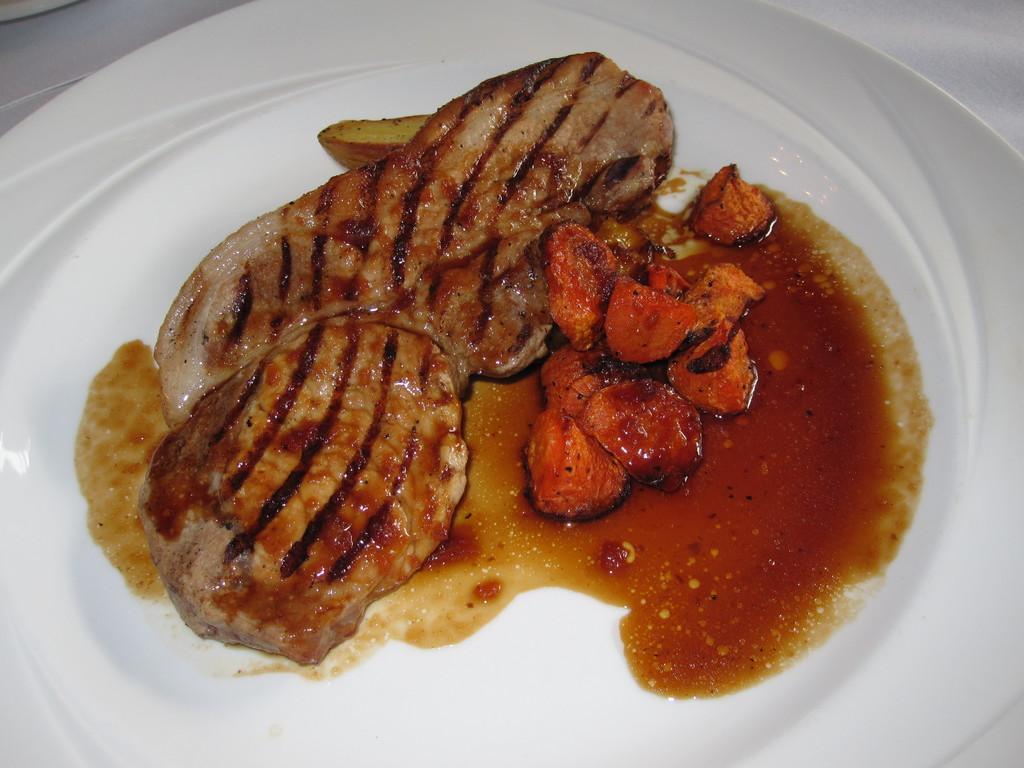Could you give a brief overview of what you see in this image? In this image we can see some food items on the plate. 